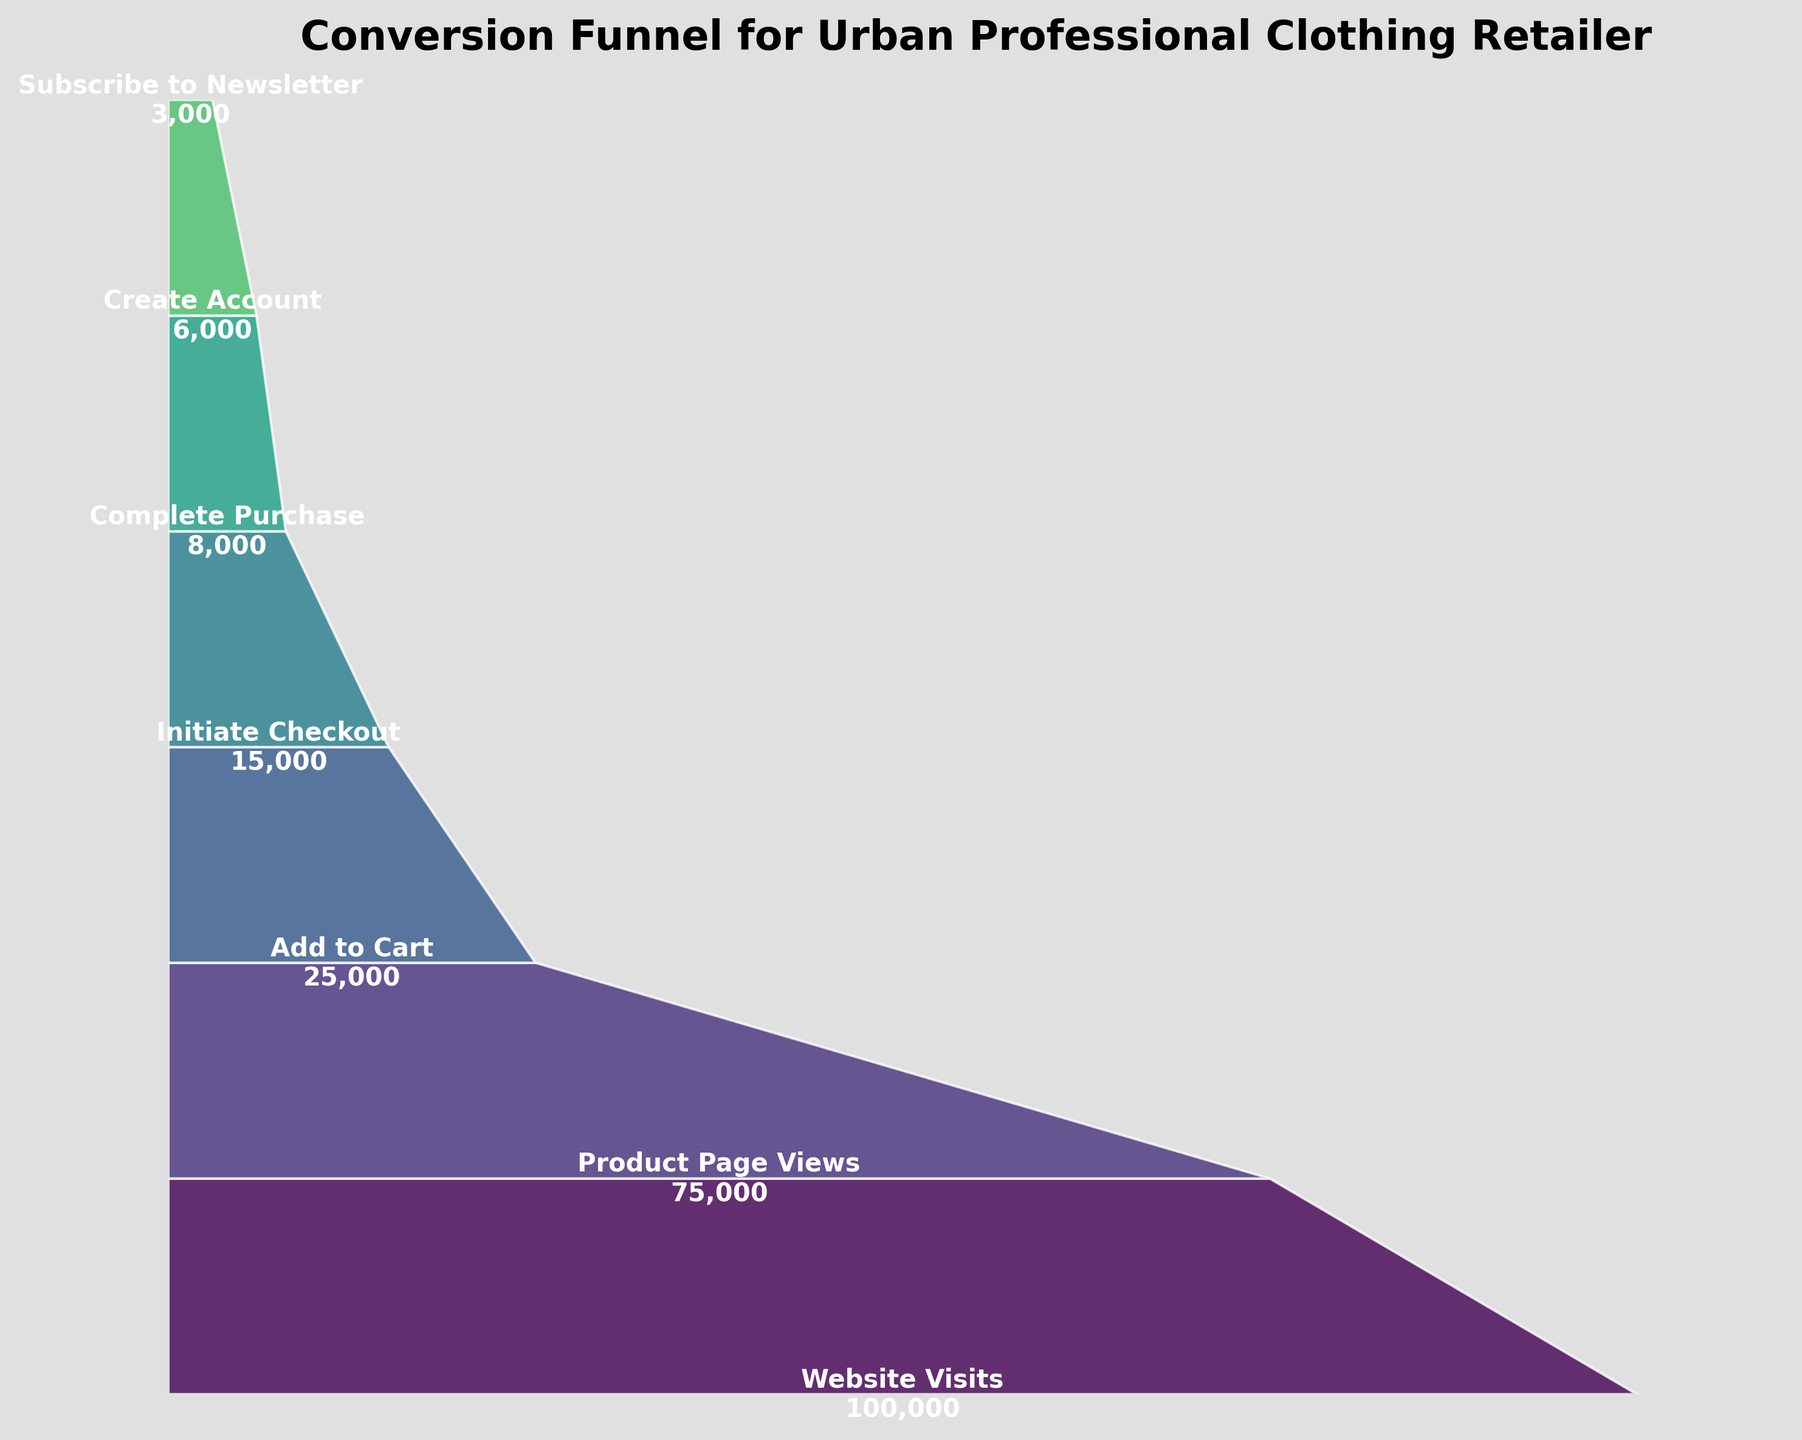What is the title of the funnel chart? The title is usually displayed prominently at the top of the chart. Here, the title is "Conversion Funnel for Urban Professional Clothing Retailer".
Answer: Conversion Funnel for Urban Professional Clothing Retailer How many stages are there in the funnel chart? To determine the number of stages, count the distinct segments or labels in the chart. In this case, the stages are Website Visits, Product Page Views, Add to Cart, Initiate Checkout, Complete Purchase, Create Account, and Subscribe to Newsletter.
Answer: 7 What is the number of users who completed a purchase? Identify the segment labeled "Complete Purchase" and read the corresponding user count. Here, it is displayed as 8,000.
Answer: 8,000 Which stage has the highest number of users? To find the stage with the highest user count, look for the widest segment at the top of the funnel, which represents the highest volume. This stage is "Website Visits" with 100,000 users.
Answer: Website Visits How many users dropped off between the stages "Add to Cart" and "Complete Purchase"? Subtract the number of users in "Complete Purchase" (8,000) from the number of users in "Add to Cart" (25,000).
Answer: 25,000 - 8,000 = 17,000 Which stage has the lowest number of users? Look for the narrowest segment at the bottom of the funnel, indicating the lowest user count. It's "Subscribe to Newsletter" with 3,000 users.
Answer: Subscribe to Newsletter What percentage of users who visited the website also subscribed to the newsletter? Divide the number of users who subscribed to the newsletter (3,000) by the total number of website visits (100,000). Multiply by 100 to get the percentage.
Answer: (3,000 / 100,000) * 100 = 3% How many more users created an account than subscribed to the newsletter? Subtract the number of users who subscribed to the newsletter (3,000) from the number of users who created an account (6,000).
Answer: 6,000 - 3,000 = 3,000 How many users proceeded from "Initiate Checkout" to "Complete Purchase"? Subtract the number of users in "Complete Purchase" (8,000) from the number of users in "Initiate Checkout" (15,000).
Answer: 15,000 - 8,000 = 7,000 What is the approximate drop-off rate between "Website Visits" and "Product Page Views"? Subtract "Product Page Views" (75,000) from "Website Visits" (100,000), then divide the result by "Website Visits". Multiply by 100 to get the percentage drop-off.
Answer: ((100,000 - 75,000) / 100,000) * 100 = 25% 